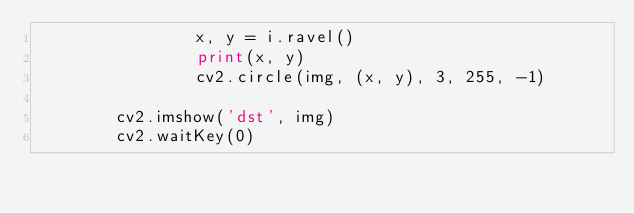Convert code to text. <code><loc_0><loc_0><loc_500><loc_500><_Python_>                x, y = i.ravel()
                print(x, y)
                cv2.circle(img, (x, y), 3, 255, -1)

        cv2.imshow('dst', img)
        cv2.waitKey(0)
</code> 